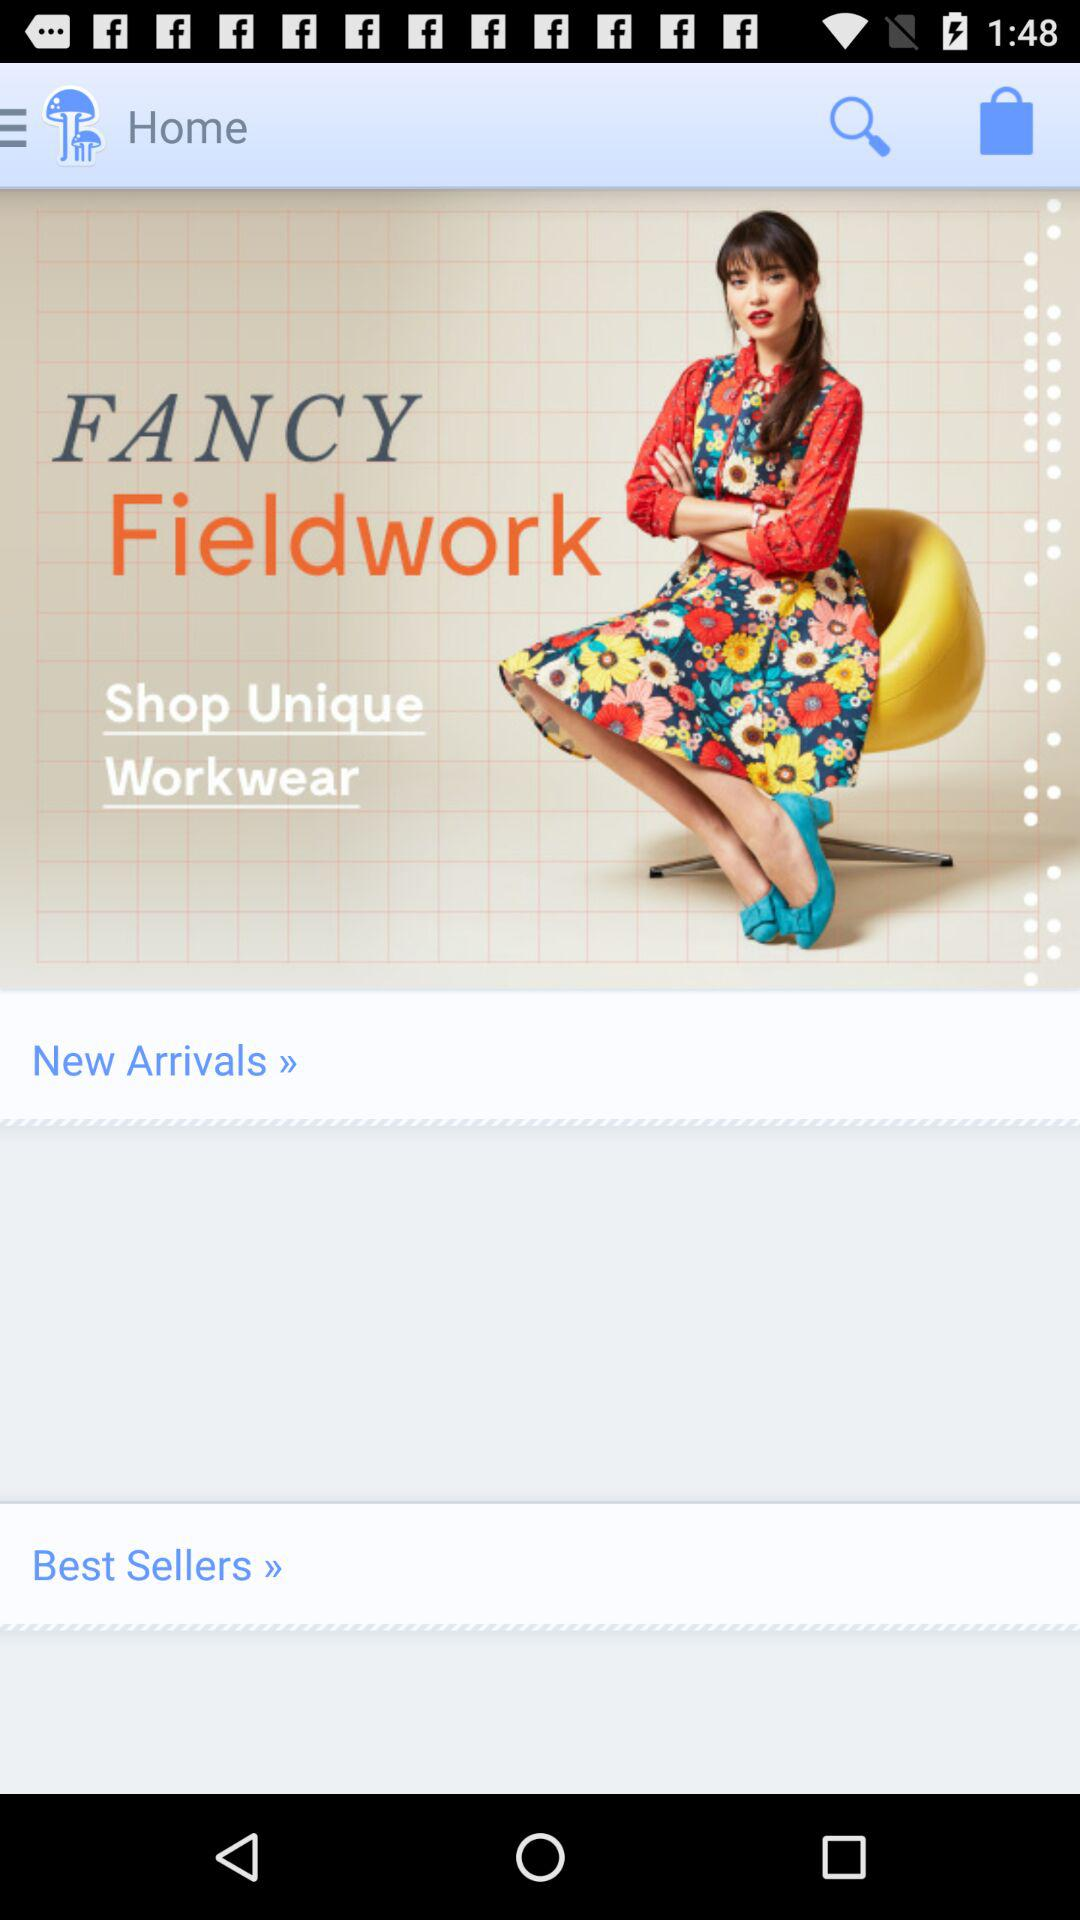What type of clothing do we shop for?
When the provided information is insufficient, respond with <no answer>. <no answer> 